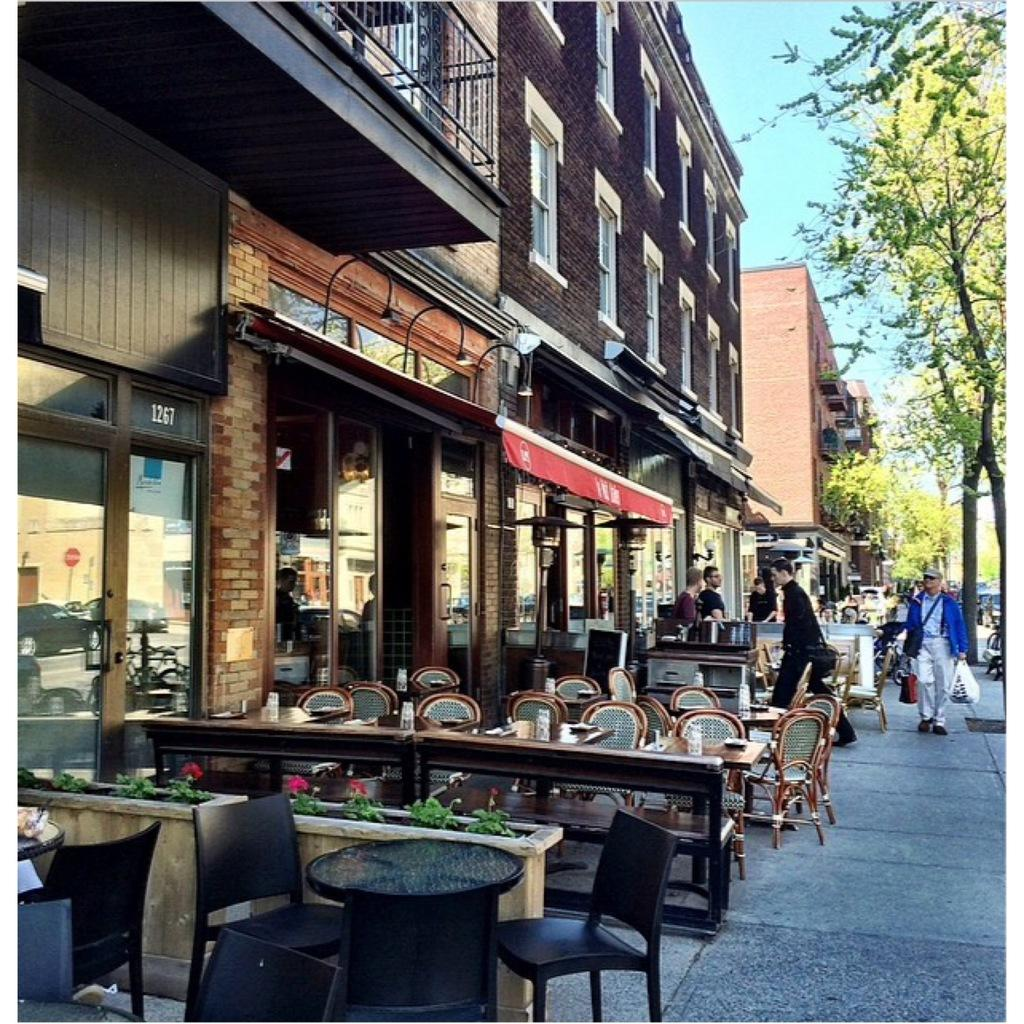What type of furniture is arranged in the image? There are chairs around a table in the image. What can be seen on the right side of the image? There are people on the right side of the image. What type of structures are visible in the image? There are buildings visible in the image. What type of vegetation is present in the image? Trees are present in the image. What is visible in the background of the image? The sky is visible in the background of the image. Can you tell me how many toes the people on the right side of the image have? The number of toes cannot be determined from the image, as it only shows people from the waist up. What type of slave is depicted in the image? There is no depiction of a slave in the image; it features chairs, a table, people, buildings, trees, and the sky. 